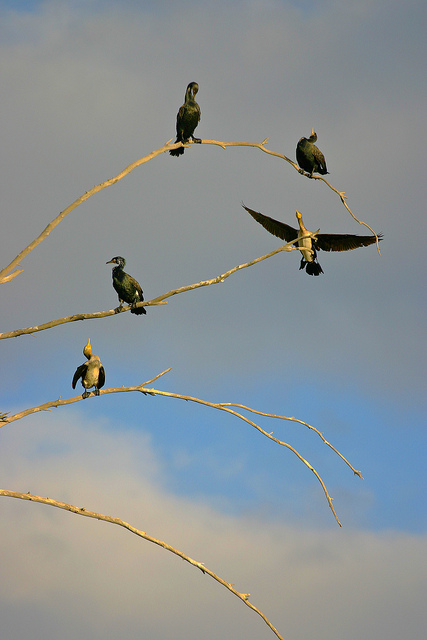Are these birds of the same specie? Upon closer observation, the birds are not of the same species, as indicated by the varied features and colorations amongst them. 